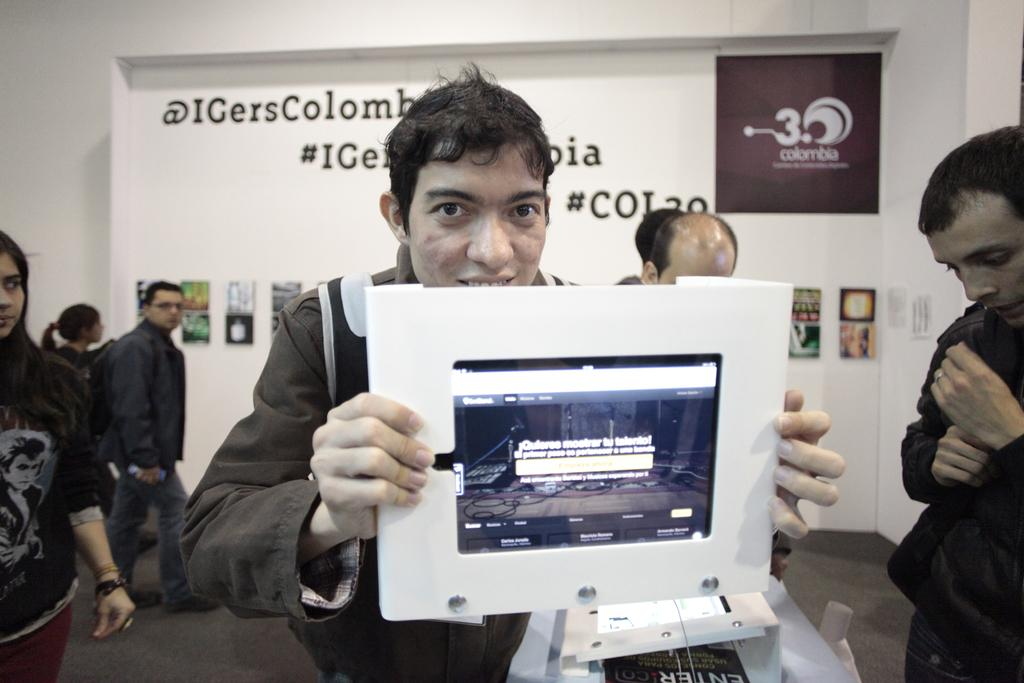What is the man in the image holding? The man is holding a screen in the image. Can you describe the other people in the image? There are other persons in the image, but their specific actions or features are not mentioned in the provided facts. What can be seen in the background of the image? There is a banner and a wall in the background of the image. What type of yard can be seen in the image? There is no yard present in the image. Is there a swing visible in the image? There is no swing present in the image. 